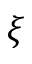<formula> <loc_0><loc_0><loc_500><loc_500>\xi</formula> 